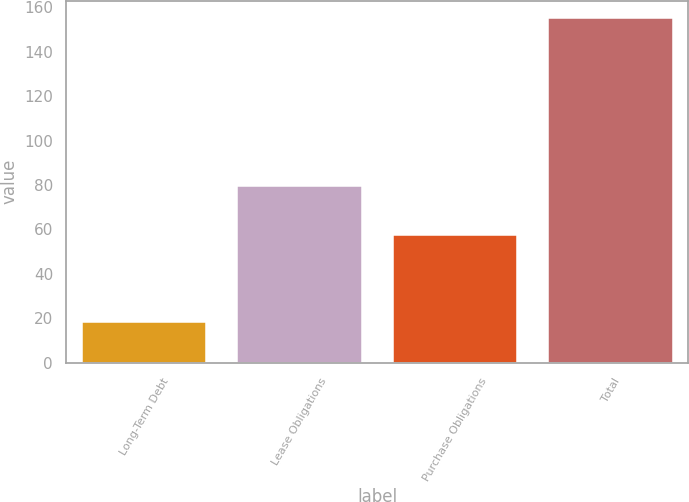Convert chart to OTSL. <chart><loc_0><loc_0><loc_500><loc_500><bar_chart><fcel>Long-Term Debt<fcel>Lease Obligations<fcel>Purchase Obligations<fcel>Total<nl><fcel>18.2<fcel>79.4<fcel>57.5<fcel>155.1<nl></chart> 